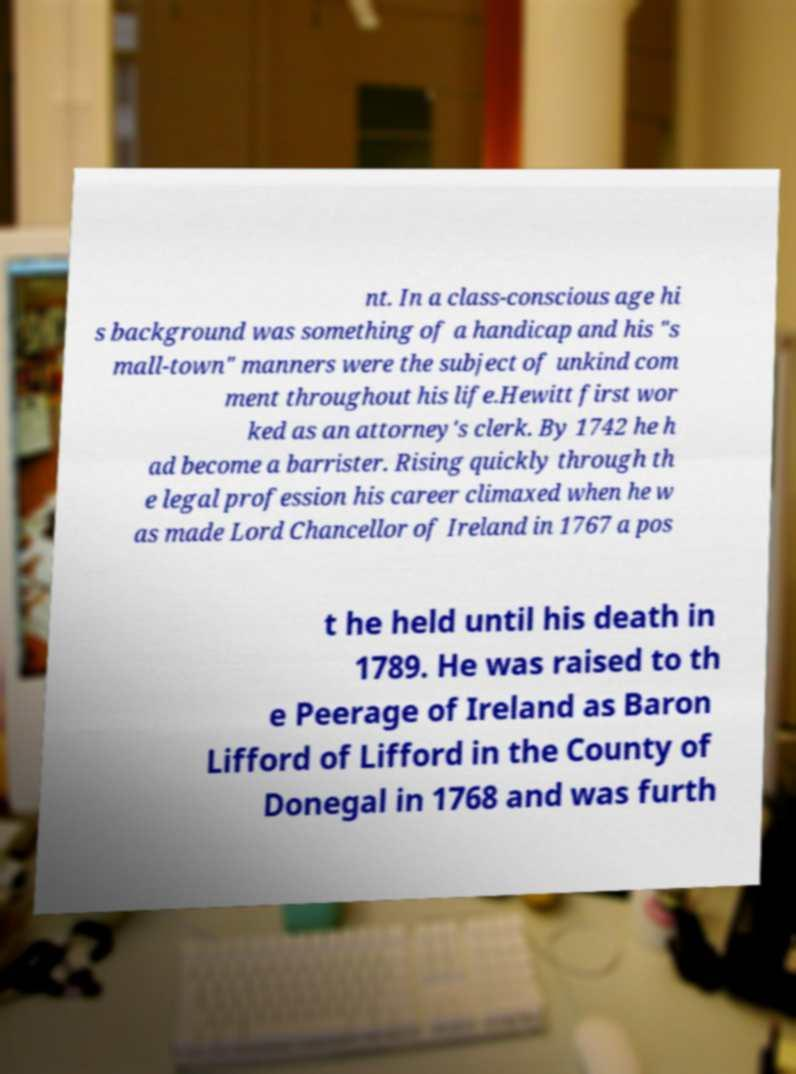There's text embedded in this image that I need extracted. Can you transcribe it verbatim? nt. In a class-conscious age hi s background was something of a handicap and his "s mall-town" manners were the subject of unkind com ment throughout his life.Hewitt first wor ked as an attorney's clerk. By 1742 he h ad become a barrister. Rising quickly through th e legal profession his career climaxed when he w as made Lord Chancellor of Ireland in 1767 a pos t he held until his death in 1789. He was raised to th e Peerage of Ireland as Baron Lifford of Lifford in the County of Donegal in 1768 and was furth 